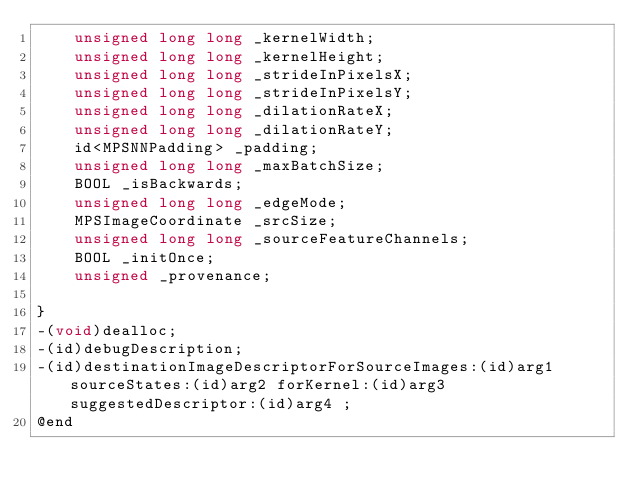Convert code to text. <code><loc_0><loc_0><loc_500><loc_500><_C_>	unsigned long long _kernelWidth;
	unsigned long long _kernelHeight;
	unsigned long long _strideInPixelsX;
	unsigned long long _strideInPixelsY;
	unsigned long long _dilationRateX;
	unsigned long long _dilationRateY;
	id<MPSNNPadding> _padding;
	unsigned long long _maxBatchSize;
	BOOL _isBackwards;
	unsigned long long _edgeMode;
	MPSImageCoordinate _srcSize;
	unsigned long long _sourceFeatureChannels;
	BOOL _initOnce;
	unsigned _provenance;

}
-(void)dealloc;
-(id)debugDescription;
-(id)destinationImageDescriptorForSourceImages:(id)arg1 sourceStates:(id)arg2 forKernel:(id)arg3 suggestedDescriptor:(id)arg4 ;
@end

</code> 